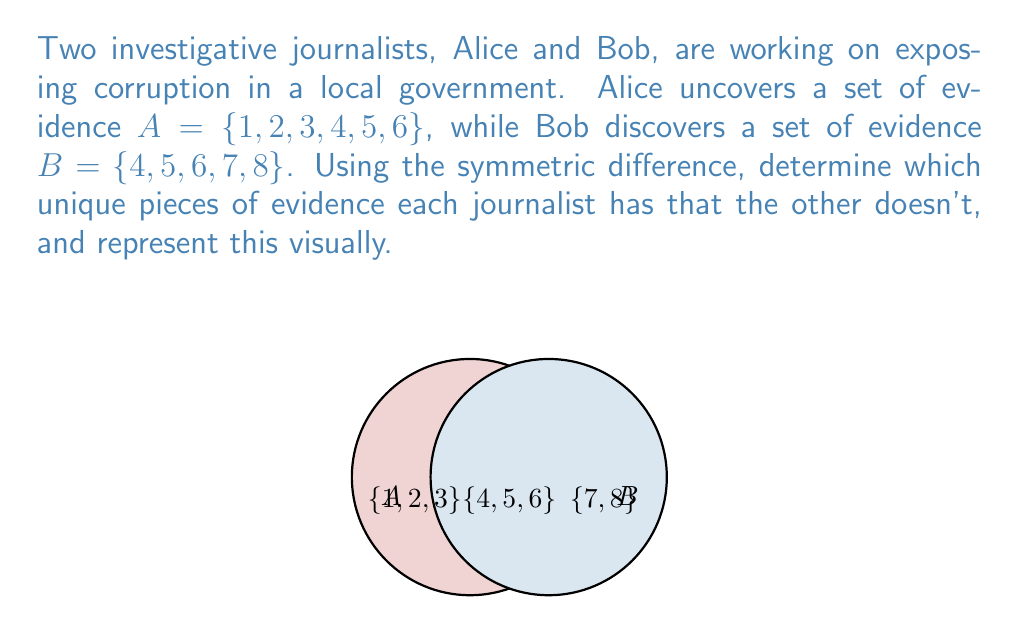Solve this math problem. To solve this problem, we need to find the symmetric difference between sets A and B. The symmetric difference of two sets is defined as the set of elements that are in either of the sets, but not in their intersection. It can be expressed using the formula:

$$ A \triangle B = (A \setminus B) \cup (B \setminus A) $$

Let's break this down step-by-step:

1) First, find $A \setminus B$ (elements in A but not in B):
   $A \setminus B = \{1, 2, 3\}$

2) Next, find $B \setminus A$ (elements in B but not in A):
   $B \setminus A = \{7, 8\}$

3) Now, we take the union of these two sets:
   $(A \setminus B) \cup (B \setminus A) = \{1, 2, 3\} \cup \{7, 8\} = \{1, 2, 3, 7, 8\}$

This result represents the unique pieces of evidence that each journalist has that the other doesn't. Specifically:
- Alice uniquely has evidence pieces {1, 2, 3}
- Bob uniquely has evidence pieces {7, 8}

The visual representation in the question shows this clearly, with the non-overlapping parts of the Venn diagram representing the symmetric difference.
Answer: $A \triangle B = \{1, 2, 3, 7, 8\}$ 